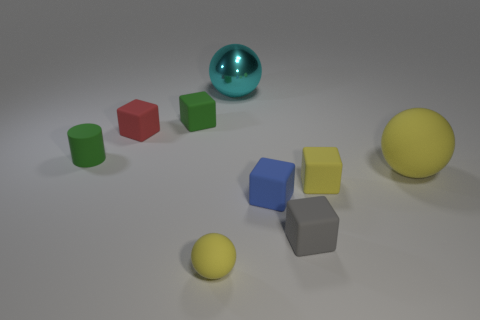Subtract all yellow cubes. How many cubes are left? 4 Subtract 2 blocks. How many blocks are left? 3 Subtract all red blocks. How many blocks are left? 4 Subtract all purple cubes. Subtract all brown cylinders. How many cubes are left? 5 Add 1 big cyan metal spheres. How many objects exist? 10 Subtract all balls. How many objects are left? 6 Subtract all tiny yellow cubes. Subtract all small green blocks. How many objects are left? 7 Add 5 tiny matte cylinders. How many tiny matte cylinders are left? 6 Add 7 tiny green cylinders. How many tiny green cylinders exist? 8 Subtract 1 green cylinders. How many objects are left? 8 